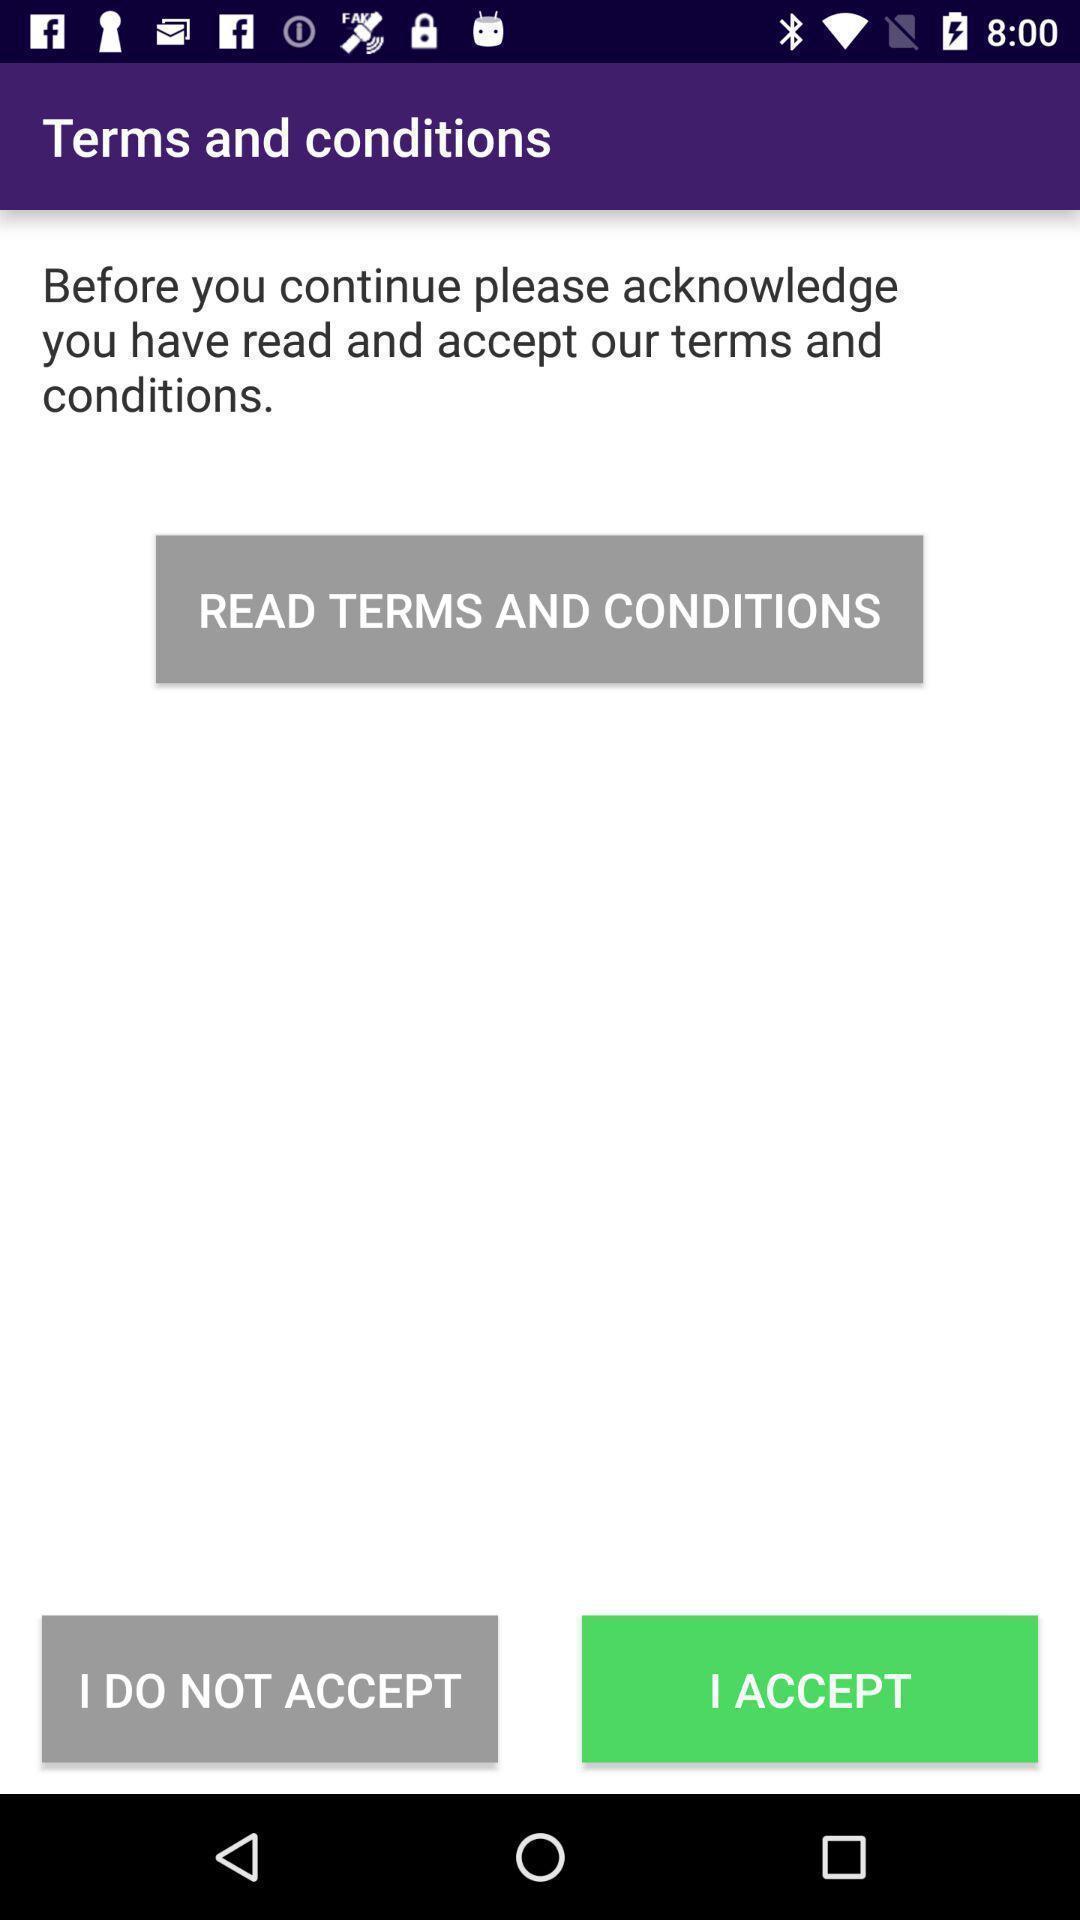Tell me what you see in this picture. Terms and conditions page with few options in health application. 